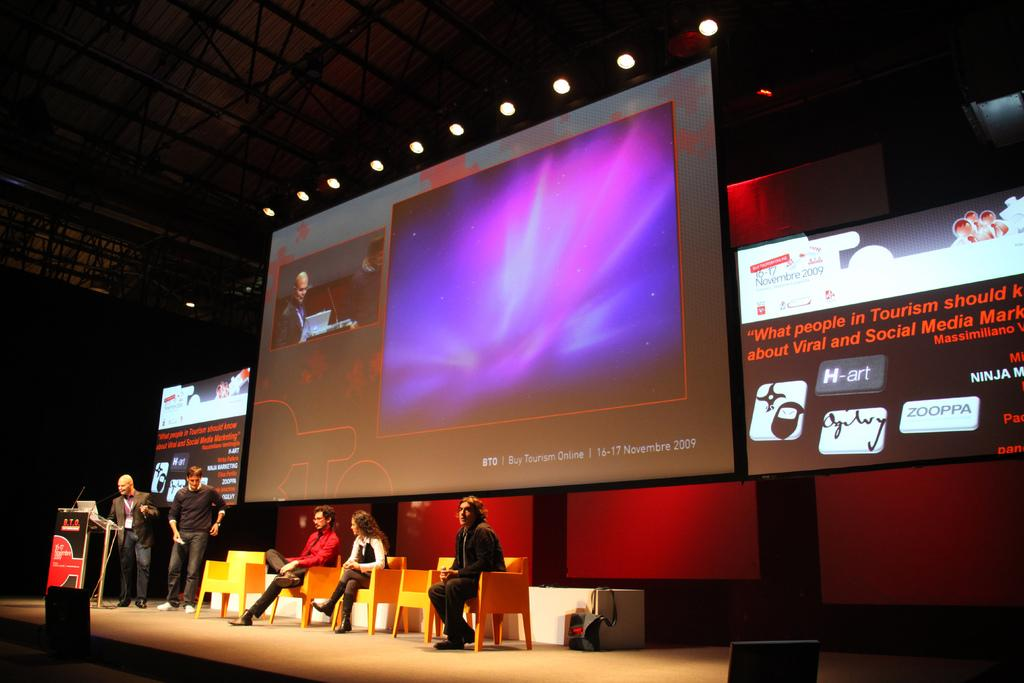Provide a one-sentence caption for the provided image. People are giving a presentation on stage about tourism. 